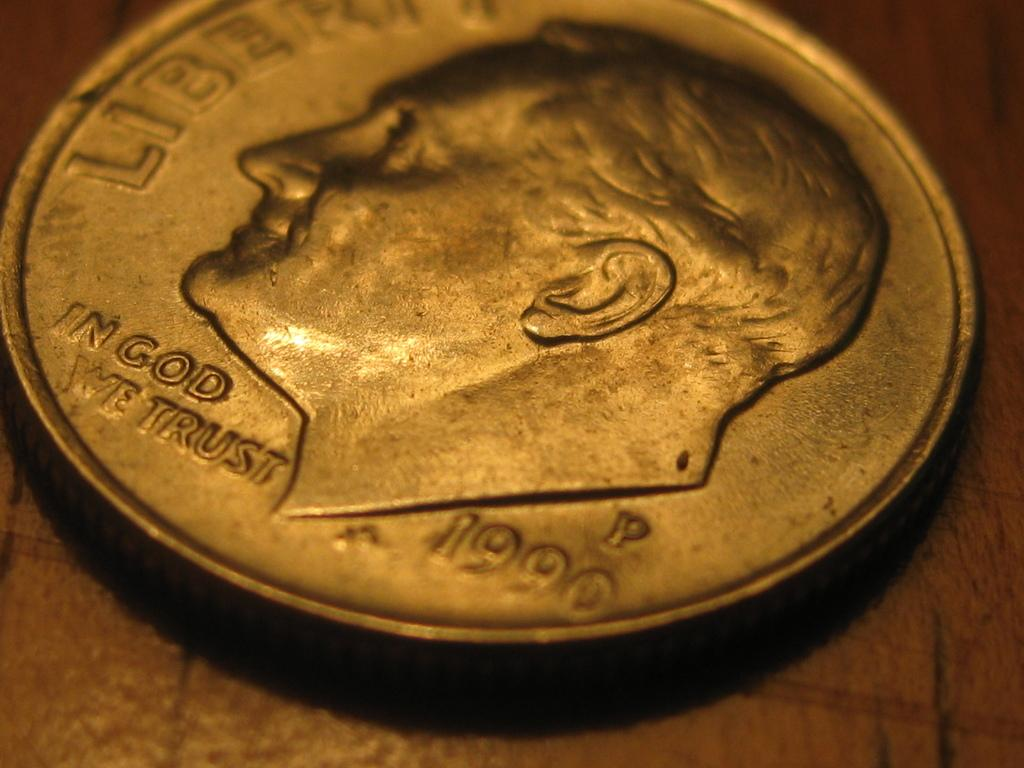<image>
Provide a brief description of the given image. The silver coin shown was made in 1990/ 